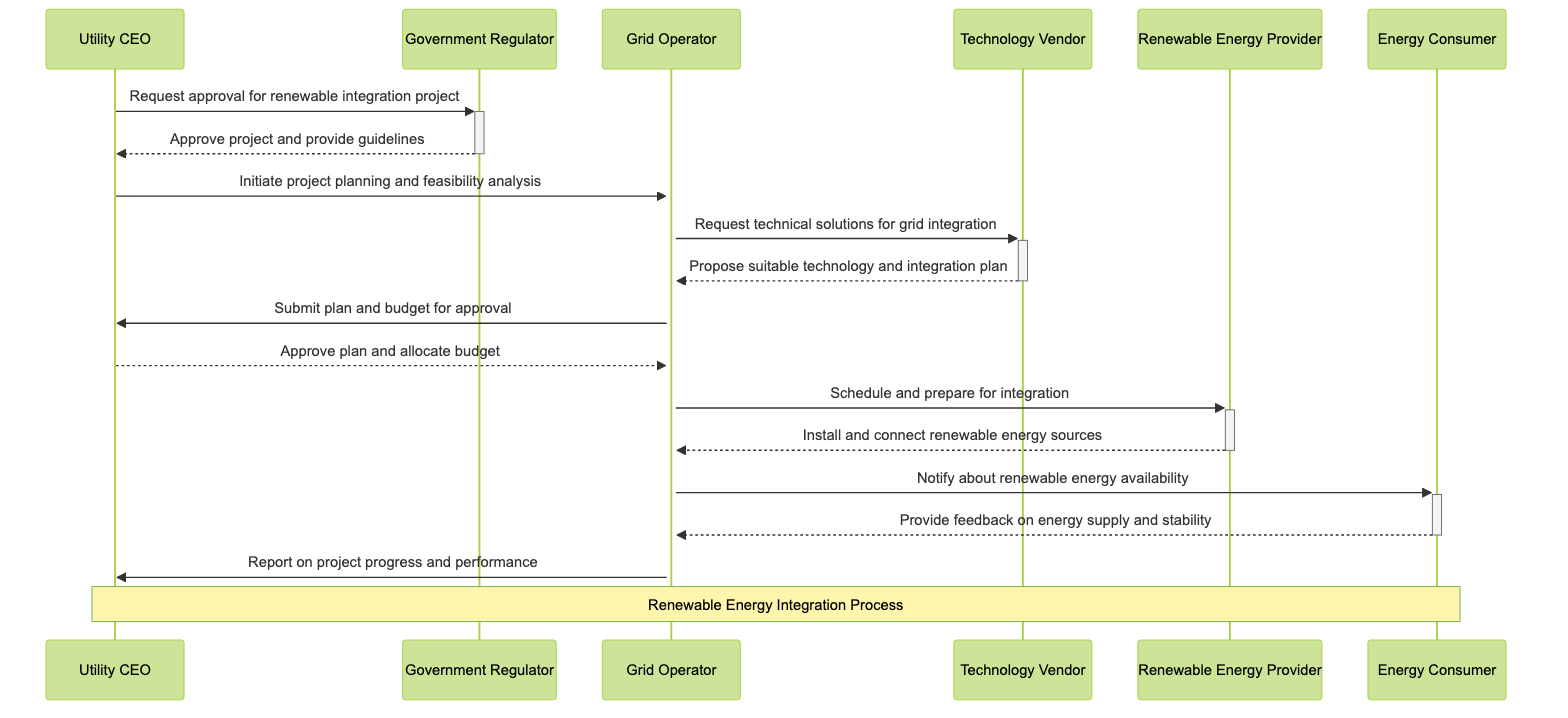What is the role of the Utility CEO? The Utility CEO's role is to initiate and oversee renewable integration projects, as indicated in the diagram where he interacts with various actors to progress the integration project.
Answer: Initiate and oversee renewable integration projects How many actors are involved in this sequence? The sequence diagram includes six actors: Utility CEO, Government Regulator, Grid Operator, Technology Vendor, Renewable Energy Provider, and Energy Consumer, which can be counted directly from the actors section of the diagram.
Answer: Six Who receives the approval request from the Utility CEO? The Utility CEO sends a request for approval to the Government Regulator, as the arrow indicating the request points from the Utility CEO to the Government Regulator in the diagram.
Answer: Government Regulator What does the Government Regulator provide after approving the project? After approving the project, the Government Regulator provides guidelines, which is mentioned in the message description flowing back to the Utility CEO.
Answer: Provide guidelines Which actor is responsible for submitting the plan and budget for approval? The Grid Operator is the actor responsible for submitting the plan and budget for approval to the Utility CEO, as shown by the direct message flow from Grid Operator to Utility CEO.
Answer: Grid Operator What action does the Renewable Energy Provider take in the integration process? The Renewable Energy Provider installs and connects renewable energy sources to the grid, as specified in the message exchanged with the Grid Operator.
Answer: Install and connect renewable energy sources What is the last interaction in the sequence? The last interaction in the sequence is the Grid Operator reporting on project progress and performance to the Utility CEO, shown as the final arrow pointing to the Utility CEO in the diagram.
Answer: Report on project progress and performance How many messages are exchanged between the actors in total? There are a total of eleven messages exchanged among the actors, which can be counted from the messages section of the diagram.
Answer: Eleven What is the main focus of the sequence diagram? The main focus of the sequence diagram is the renewable energy integration process, which is emphasized by the note indicating the overall theme of the interactions presented in the diagram.
Answer: Renewable Energy Integration Process 